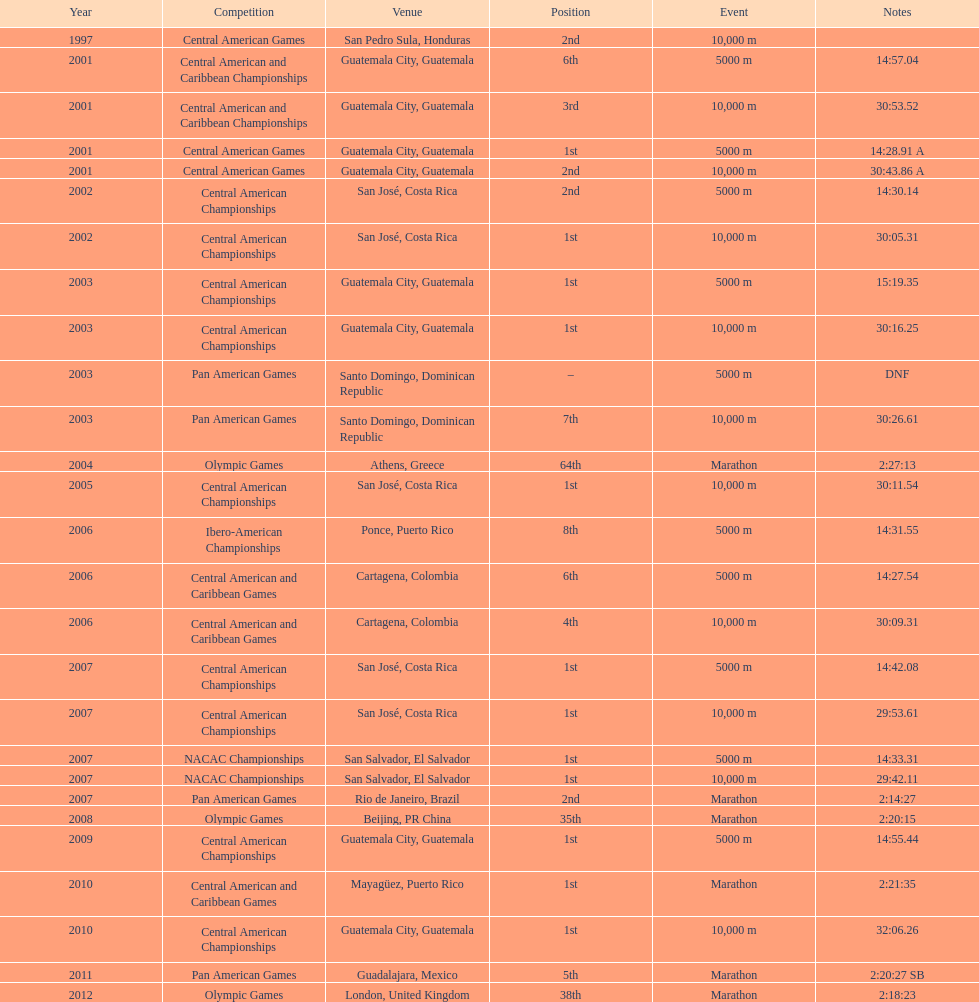What was the last competition in which a position of "2nd" was achieved? Pan American Games. 